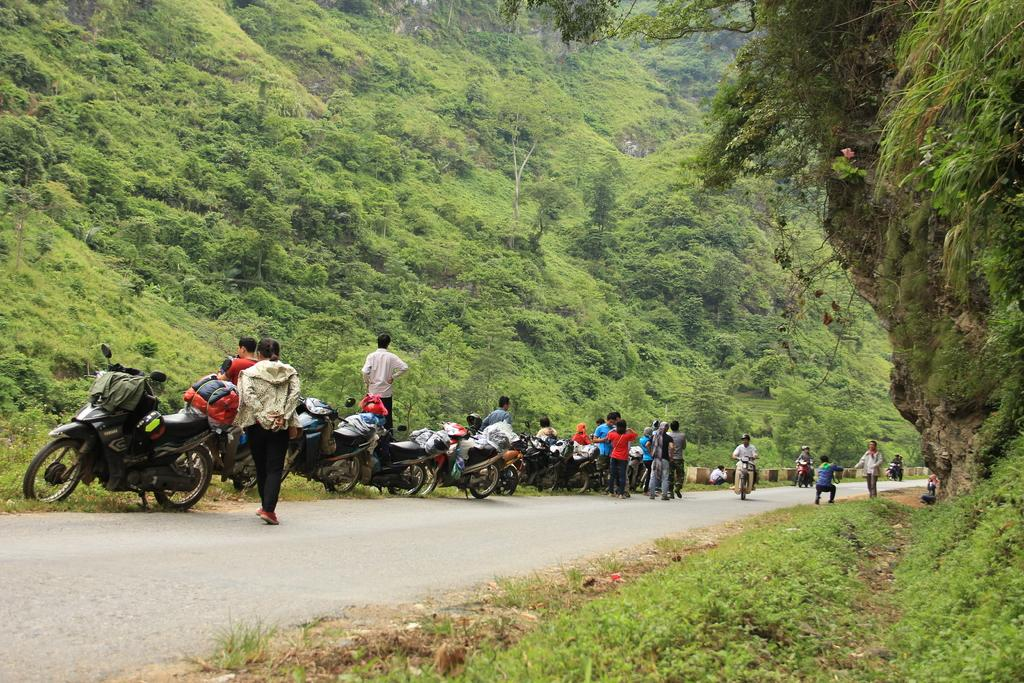What is the main feature of the image? There is a road in the image. What can be seen on the road? There are motorbikes and people on the road. What type of vegetation is visible in the image? There is grass visible in the image. What surrounds the road in the image? There are trees on both sides of the road. How many beans are scattered on the grass in the image? There are no beans present in the image; it features a road with motorbikes and people, surrounded by trees. 